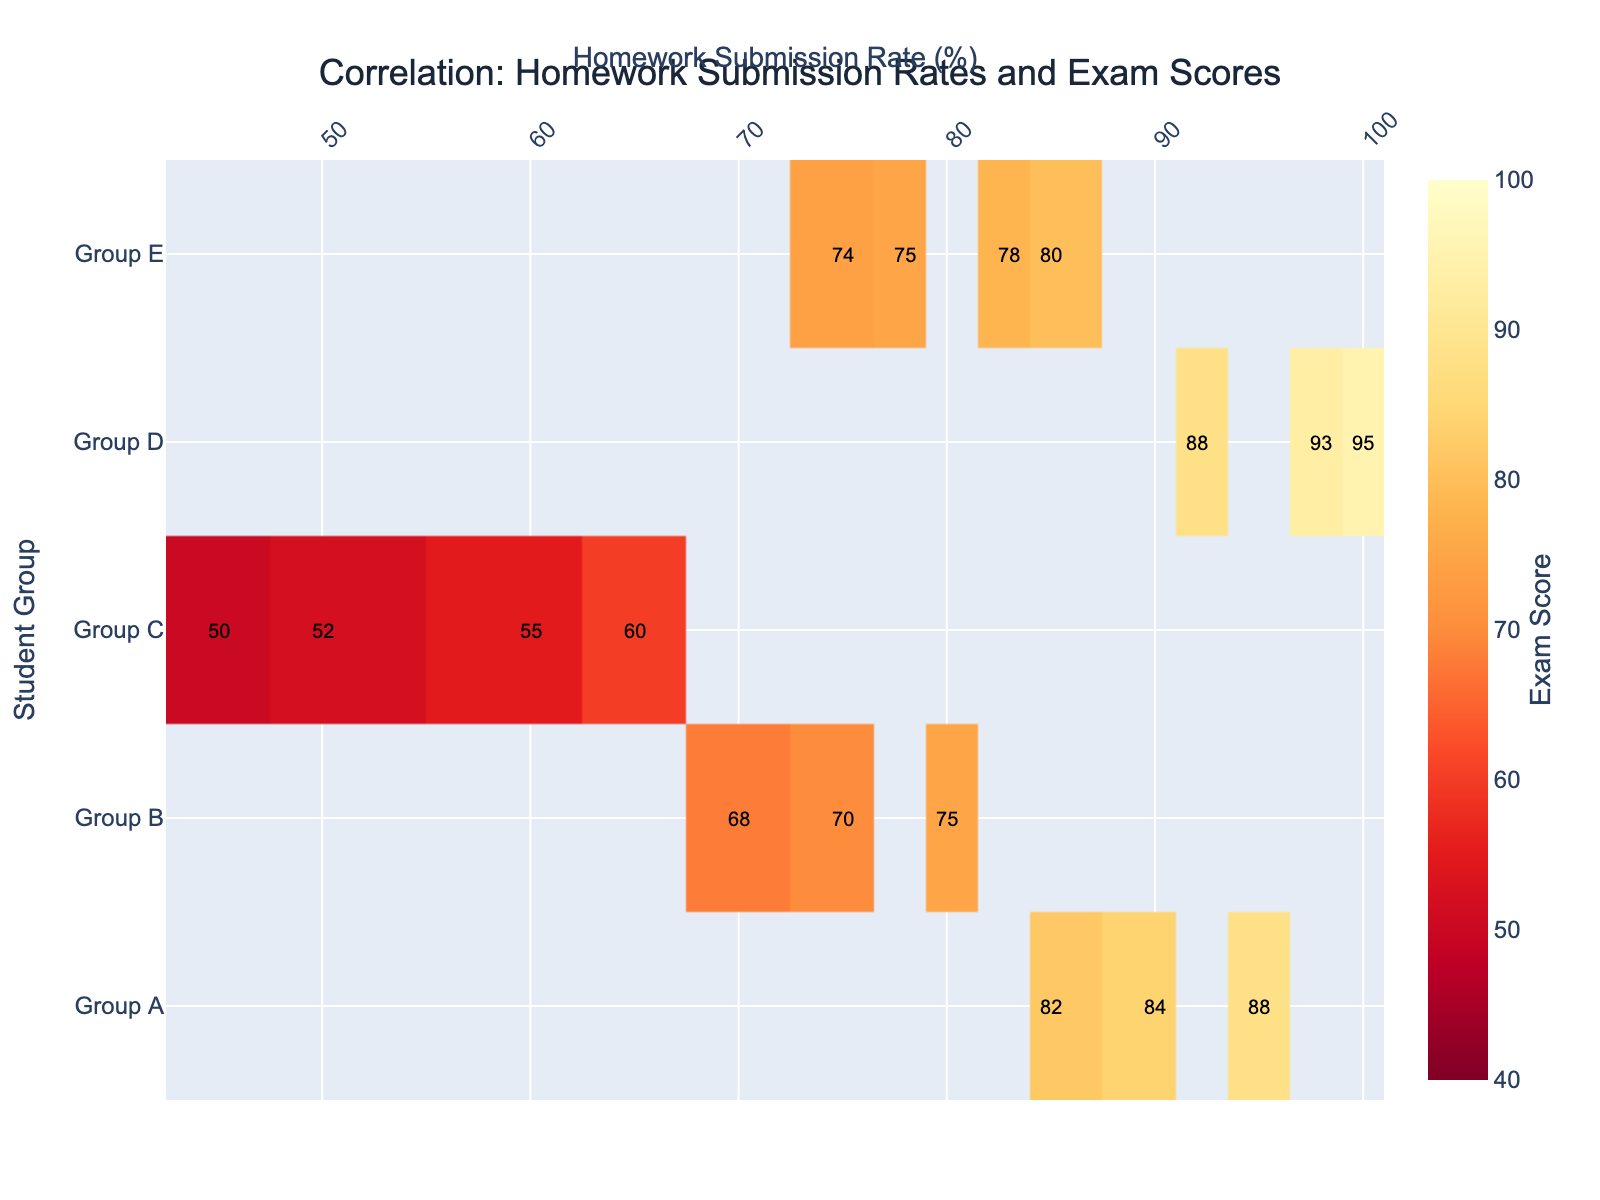What is the title of the heatmap? The title is located at the top center of the heatmap and is usually represented in a larger and bolder font.
Answer: Correlation: Homework Submission Rates and Exam Scores What are the y-axis labels? The y-axis represents the student groups. These labels are found vertically on the left side of the heatmap.
Answer: Group A, Group B, Group C, Group D, Group E What color represents the highest exam score? In a heatmap, the color representing the highest value can be identified using the color scale (legend) on the right.
Answer: Deep red Which student group has the highest exam score at the maximum homework submission rate? The heatmap's color intensity and annotations help determine the values. Locate the maximum homework submission rate on the x-axis and find the corresponding highest score on the y-axis.
Answer: Group D How many data points show an exam score above 90? Count the number of cells in the heatmap with values above 90. These cells are typically represented by a darker, more intense color.
Answer: 3 What is the average exam score for Group B? The heatmap annotations reveal individual scores for each cell representing Group B. Sum these values and divide by the number of data points to get the average. (75 + 70 + 68) / 3
Answer: 71 Which group has a median exam score of 75 or higher? Identify the groups and their exam scores using the annotations. Calculate the median for each group and compare these values to 75.
Answer: Group A, Group D, Group E Which group has the greatest variation in exam scores? Look at the range of exam scores (from the minimum to maximum values) within each student group. The group with the widest range has the greatest variation.
Answer: Group C Which student group benefits the most from higher homework submission rates? To determine this, observe the trend in exam scores as the homework submission rate increases for each group. The group with the steepest positive gradient in exam scores benefits the most.
Answer: Group D 